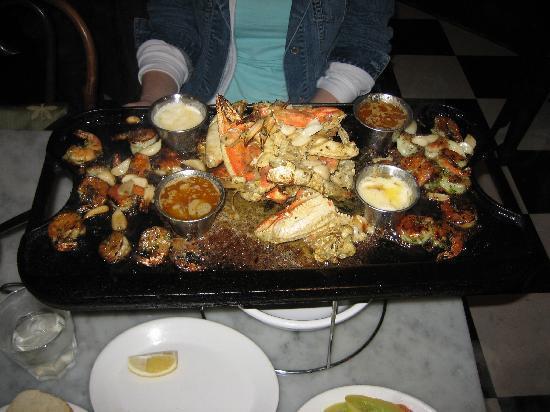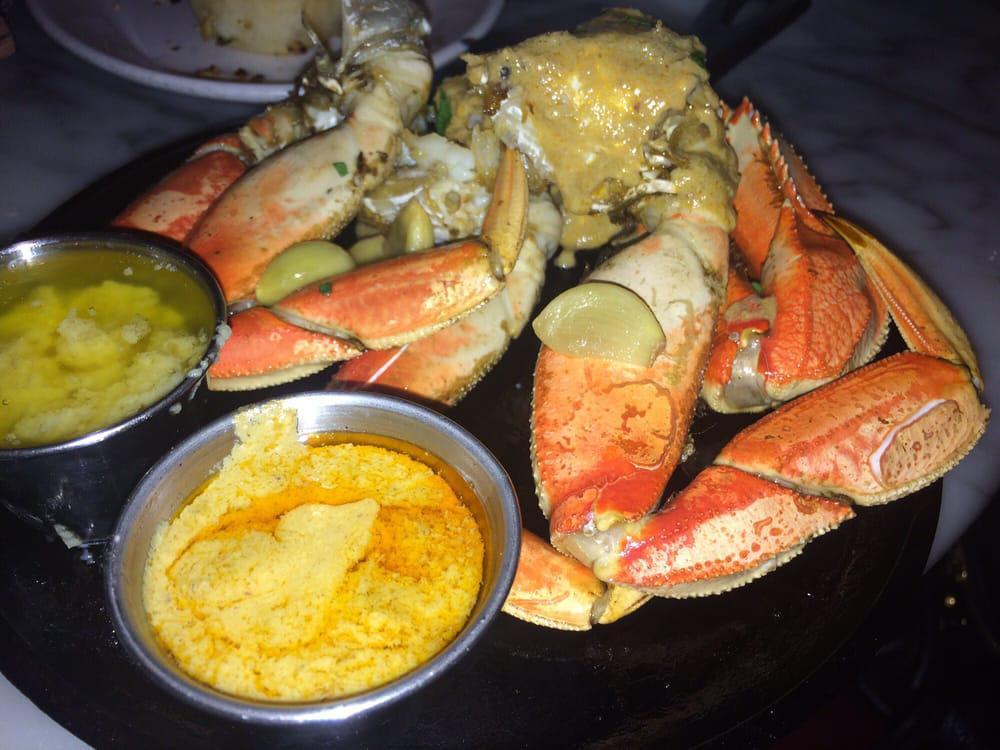The first image is the image on the left, the second image is the image on the right. Considering the images on both sides, is "there is a meal of crab on a plate with two silver bowls with condiments in them" valid? Answer yes or no. Yes. The first image is the image on the left, the second image is the image on the right. Examine the images to the left and right. Is the description "One image features crab and two silver bowls of liquid on a round black tray, and the other image features crab on a rectangular black tray." accurate? Answer yes or no. Yes. 